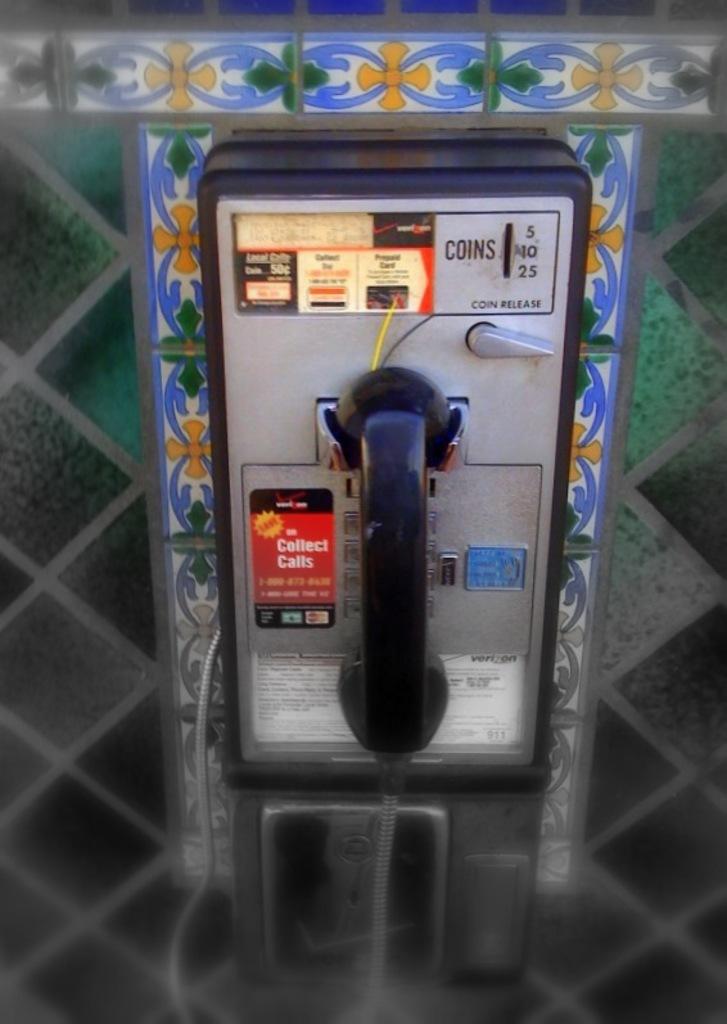What type of slot is located above the lever?
Ensure brevity in your answer.  Coins. 